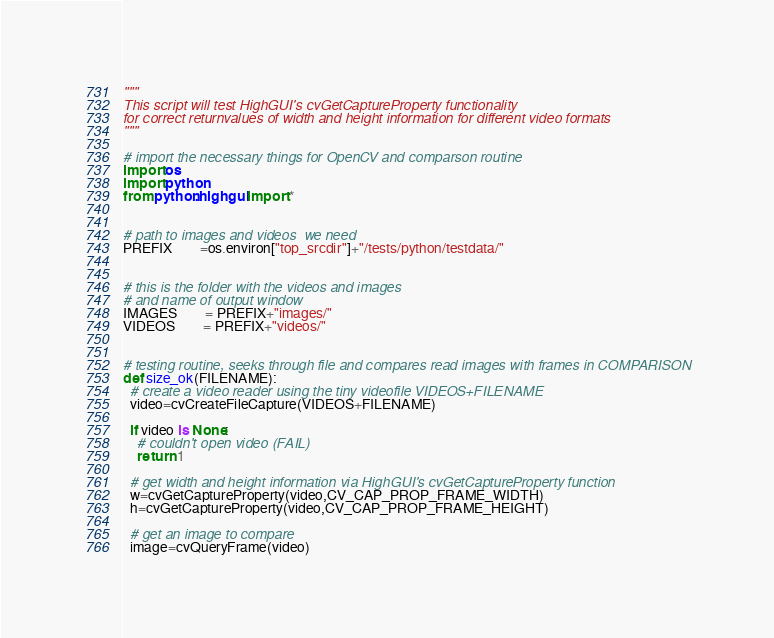Convert code to text. <code><loc_0><loc_0><loc_500><loc_500><_Python_>"""
This script will test HighGUI's cvGetCaptureProperty functionality
for correct returnvalues of width and height information for different video formats
"""

# import the necessary things for OpenCV and comparson routine
import os
import python
from python.highgui import *


# path to images and videos  we need
PREFIX		=os.environ["top_srcdir"]+"/tests/python/testdata/"


# this is the folder with the videos and images
# and name of output window
IMAGES		= PREFIX+"images/"
VIDEOS		= PREFIX+"videos/"


# testing routine, seeks through file and compares read images with frames in COMPARISON
def size_ok(FILENAME):
  # create a video reader using the tiny videofile VIDEOS+FILENAME
  video=cvCreateFileCapture(VIDEOS+FILENAME)

  if video is None:
    # couldn't open video (FAIL)
    return 1

  # get width and height information via HighGUI's cvGetCaptureProperty function
  w=cvGetCaptureProperty(video,CV_CAP_PROP_FRAME_WIDTH)
  h=cvGetCaptureProperty(video,CV_CAP_PROP_FRAME_HEIGHT)

  # get an image to compare
  image=cvQueryFrame(video)
</code> 